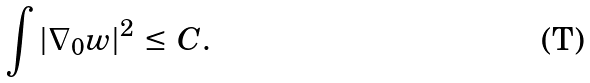<formula> <loc_0><loc_0><loc_500><loc_500>\int | \nabla _ { 0 } w | ^ { 2 } \, \leq \, C .</formula> 